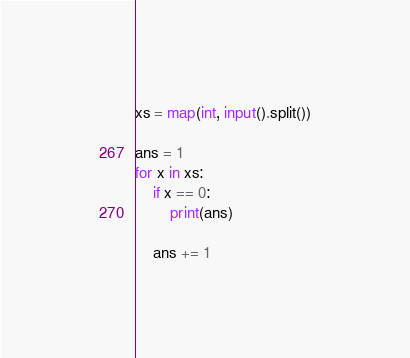<code> <loc_0><loc_0><loc_500><loc_500><_Python_>xs = map(int, input().split())

ans = 1
for x in xs:
    if x == 0:
        print(ans)

    ans += 1
</code> 